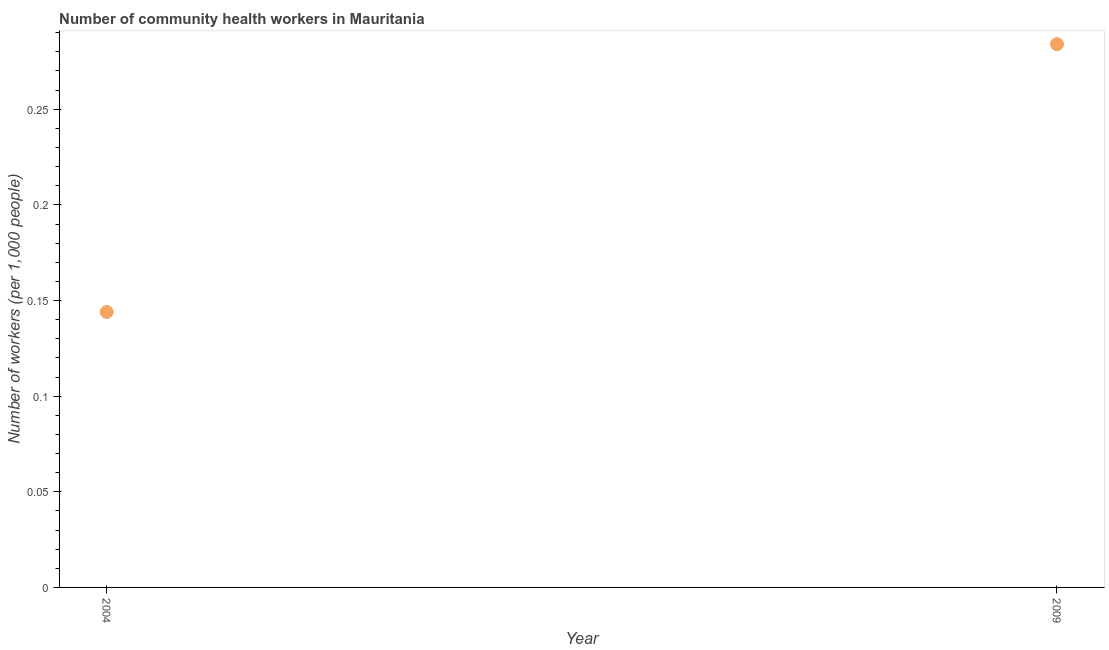What is the number of community health workers in 2009?
Make the answer very short. 0.28. Across all years, what is the maximum number of community health workers?
Offer a very short reply. 0.28. Across all years, what is the minimum number of community health workers?
Your answer should be compact. 0.14. In which year was the number of community health workers minimum?
Provide a short and direct response. 2004. What is the sum of the number of community health workers?
Offer a terse response. 0.43. What is the difference between the number of community health workers in 2004 and 2009?
Your response must be concise. -0.14. What is the average number of community health workers per year?
Provide a short and direct response. 0.21. What is the median number of community health workers?
Your answer should be compact. 0.21. In how many years, is the number of community health workers greater than 0.22 ?
Your answer should be compact. 1. Do a majority of the years between 2009 and 2004 (inclusive) have number of community health workers greater than 0.060000000000000005 ?
Provide a short and direct response. No. What is the ratio of the number of community health workers in 2004 to that in 2009?
Offer a terse response. 0.51. How many dotlines are there?
Your response must be concise. 1. What is the difference between two consecutive major ticks on the Y-axis?
Keep it short and to the point. 0.05. Does the graph contain grids?
Make the answer very short. No. What is the title of the graph?
Make the answer very short. Number of community health workers in Mauritania. What is the label or title of the Y-axis?
Offer a very short reply. Number of workers (per 1,0 people). What is the Number of workers (per 1,000 people) in 2004?
Offer a terse response. 0.14. What is the Number of workers (per 1,000 people) in 2009?
Your answer should be compact. 0.28. What is the difference between the Number of workers (per 1,000 people) in 2004 and 2009?
Ensure brevity in your answer.  -0.14. What is the ratio of the Number of workers (per 1,000 people) in 2004 to that in 2009?
Your answer should be very brief. 0.51. 